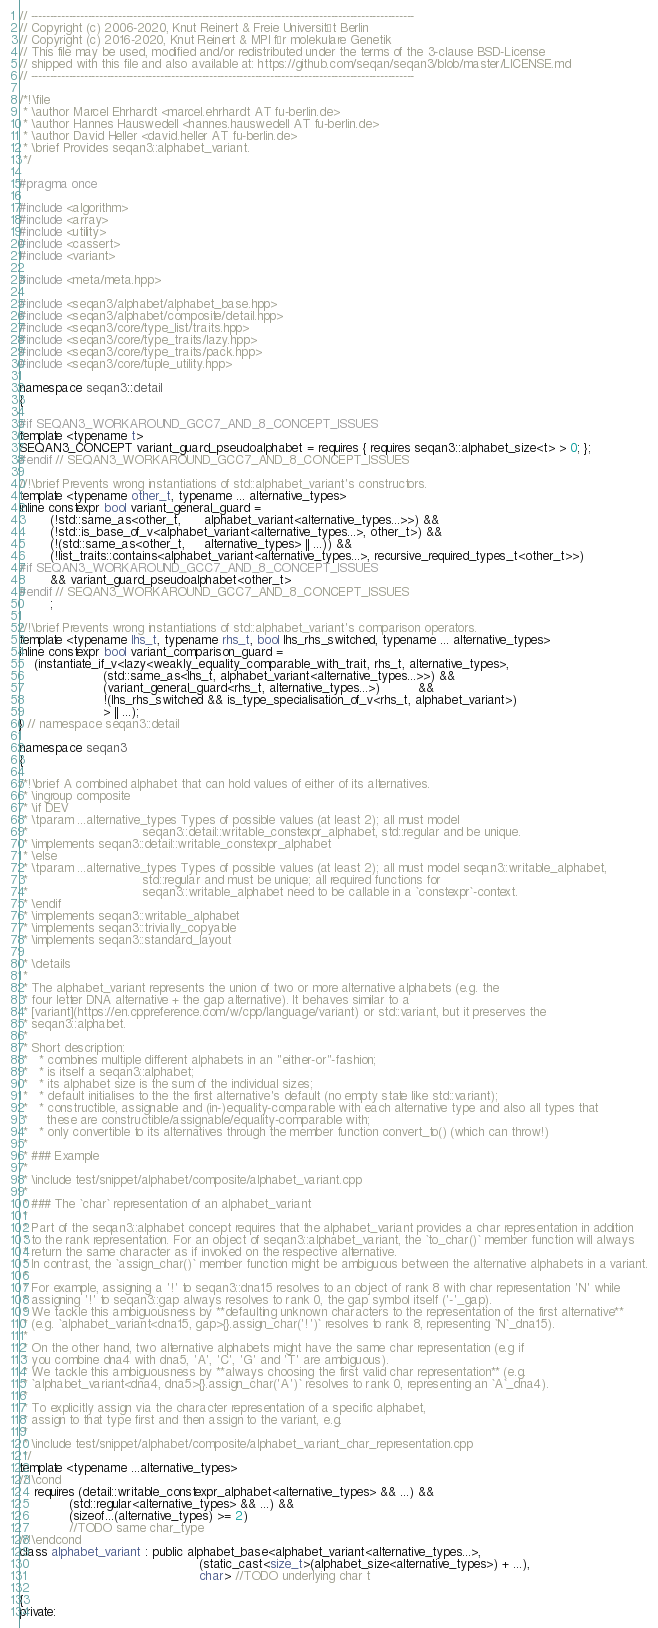<code> <loc_0><loc_0><loc_500><loc_500><_C++_>// -----------------------------------------------------------------------------------------------------
// Copyright (c) 2006-2020, Knut Reinert & Freie Universität Berlin
// Copyright (c) 2016-2020, Knut Reinert & MPI für molekulare Genetik
// This file may be used, modified and/or redistributed under the terms of the 3-clause BSD-License
// shipped with this file and also available at: https://github.com/seqan/seqan3/blob/master/LICENSE.md
// -----------------------------------------------------------------------------------------------------

/*!\file
 * \author Marcel Ehrhardt <marcel.ehrhardt AT fu-berlin.de>
 * \author Hannes Hauswedell <hannes.hauswedell AT fu-berlin.de>
 * \author David Heller <david.heller AT fu-berlin.de>
 * \brief Provides seqan3::alphabet_variant.
 */

#pragma once

#include <algorithm>
#include <array>
#include <utility>
#include <cassert>
#include <variant>

#include <meta/meta.hpp>

#include <seqan3/alphabet/alphabet_base.hpp>
#include <seqan3/alphabet/composite/detail.hpp>
#include <seqan3/core/type_list/traits.hpp>
#include <seqan3/core/type_traits/lazy.hpp>
#include <seqan3/core/type_traits/pack.hpp>
#include <seqan3/core/tuple_utility.hpp>

namespace seqan3::detail
{

#if SEQAN3_WORKAROUND_GCC7_AND_8_CONCEPT_ISSUES
template <typename t>
SEQAN3_CONCEPT variant_guard_pseudoalphabet = requires { requires seqan3::alphabet_size<t> > 0; };
#endif // SEQAN3_WORKAROUND_GCC7_AND_8_CONCEPT_ISSUES

//!\brief Prevents wrong instantiations of std::alphabet_variant's constructors.
template <typename other_t, typename ... alternative_types>
inline constexpr bool variant_general_guard =
        (!std::same_as<other_t,      alphabet_variant<alternative_types...>>) &&
        (!std::is_base_of_v<alphabet_variant<alternative_types...>, other_t>) &&
        (!(std::same_as<other_t,     alternative_types> || ...)) &&
        (!list_traits::contains<alphabet_variant<alternative_types...>, recursive_required_types_t<other_t>>)
#if SEQAN3_WORKAROUND_GCC7_AND_8_CONCEPT_ISSUES
        && variant_guard_pseudoalphabet<other_t>
#endif // SEQAN3_WORKAROUND_GCC7_AND_8_CONCEPT_ISSUES
        ;

//!\brief Prevents wrong instantiations of std::alphabet_variant's comparison operators.
template <typename lhs_t, typename rhs_t, bool lhs_rhs_switched, typename ... alternative_types>
inline constexpr bool variant_comparison_guard =
    (instantiate_if_v<lazy<weakly_equality_comparable_with_trait, rhs_t, alternative_types>,
                      (std::same_as<lhs_t, alphabet_variant<alternative_types...>>) &&
                      (variant_general_guard<rhs_t, alternative_types...>)          &&
                      !(lhs_rhs_switched && is_type_specialisation_of_v<rhs_t, alphabet_variant>)
                      > || ...);
} // namespace seqan3::detail

namespace seqan3
{

/*!\brief A combined alphabet that can hold values of either of its alternatives.
 * \ingroup composite
 * \if DEV
 * \tparam ...alternative_types Types of possible values (at least 2); all must model
 *                              seqan3::detail::writable_constexpr_alphabet, std::regular and be unique.
 * \implements seqan3::detail::writable_constexpr_alphabet
 * \else
 * \tparam ...alternative_types Types of possible values (at least 2); all must model seqan3::writable_alphabet,
 *                              std::regular and must be unique; all required functions for
 *                              seqan3::writable_alphabet need to be callable in a `constexpr`-context.
 * \endif
 * \implements seqan3::writable_alphabet
 * \implements seqan3::trivially_copyable
 * \implements seqan3::standard_layout

 * \details
 *
 * The alphabet_variant represents the union of two or more alternative alphabets (e.g. the
 * four letter DNA alternative + the gap alternative). It behaves similar to a
 * [variant](https://en.cppreference.com/w/cpp/language/variant) or std::variant, but it preserves the
 * seqan3::alphabet.
 *
 * Short description:
 *   * combines multiple different alphabets in an "either-or"-fashion;
 *   * is itself a seqan3::alphabet;
 *   * its alphabet size is the sum of the individual sizes;
 *   * default initialises to the the first alternative's default (no empty state like std::variant);
 *   * constructible, assignable and (in-)equality-comparable with each alternative type and also all types that
 *     these are constructible/assignable/equality-comparable with;
 *   * only convertible to its alternatives through the member function convert_to() (which can throw!)
 *
 * ### Example
 *
 * \include test/snippet/alphabet/composite/alphabet_variant.cpp
 *
 * ### The `char` representation of an alphabet_variant
 *
 * Part of the seqan3::alphabet concept requires that the alphabet_variant provides a char representation in addition
 * to the rank representation. For an object of seqan3::alphabet_variant, the `to_char()` member function will always
 * return the same character as if invoked on the respective alternative.
 * In contrast, the `assign_char()` member function might be ambiguous between the alternative alphabets in a variant.
 *
 * For example, assigning a '!' to seqan3::dna15 resolves to an object of rank 8 with char representation 'N' while
 * assigning '!' to seqan3::gap always resolves to rank 0, the gap symbol itself ('-'_gap).
 * We tackle this ambiguousness by **defaulting unknown characters to the representation of the first alternative**
 * (e.g. `alphabet_variant<dna15, gap>{}.assign_char('!')` resolves to rank 8, representing `N`_dna15).
 *
 * On the other hand, two alternative alphabets might have the same char representation (e.g if
 * you combine dna4 with dna5, 'A', 'C', 'G' and 'T' are ambiguous).
 * We tackle this ambiguousness by **always choosing the first valid char representation** (e.g.
 * `alphabet_variant<dna4, dna5>{}.assign_char('A')` resolves to rank 0, representing an `A`_dna4).
 *
 * To explicitly assign via the character representation of a specific alphabet,
 * assign to that type first and then assign to the variant, e.g.
 *
 * \include test/snippet/alphabet/composite/alphabet_variant_char_representation.cpp
 */
template <typename ...alternative_types>
//!\cond
    requires (detail::writable_constexpr_alphabet<alternative_types> && ...) &&
             (std::regular<alternative_types> && ...) &&
             (sizeof...(alternative_types) >= 2)
             //TODO same char_type
//!\endcond
class alphabet_variant : public alphabet_base<alphabet_variant<alternative_types...>,
                                               (static_cast<size_t>(alphabet_size<alternative_types>) + ...),
                                               char> //TODO underlying char t

{
private:</code> 